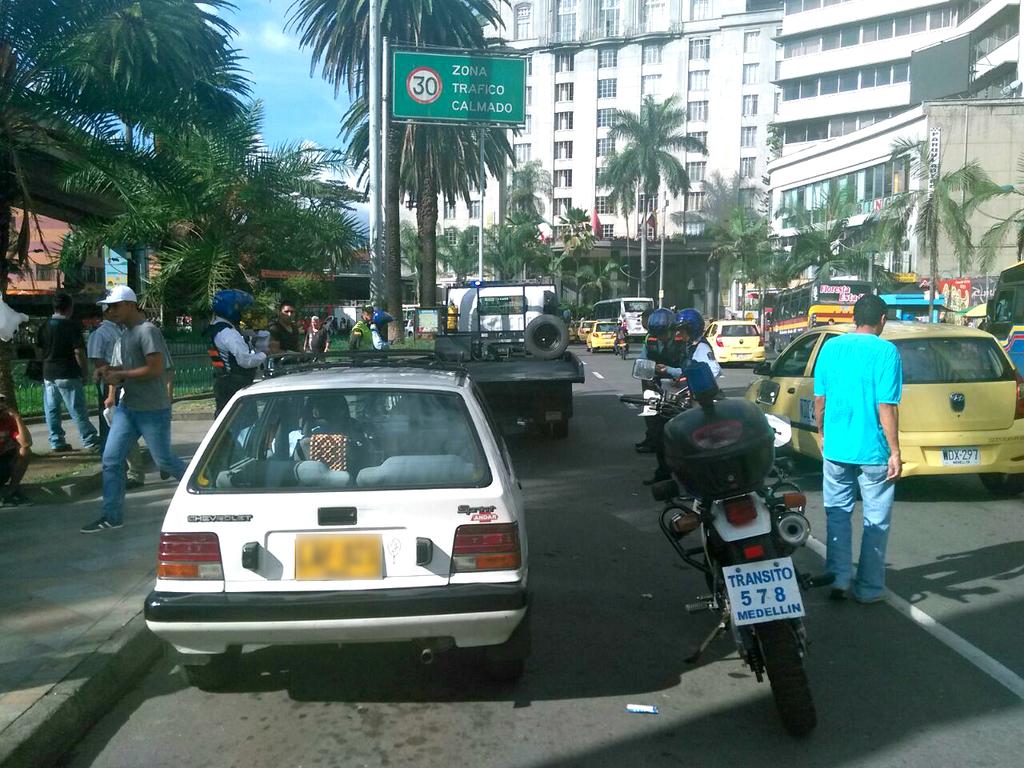What is the number of the motorcycle?
Provide a succinct answer. 578. What does the green sing says?
Your response must be concise. Zona trafico calmado. 